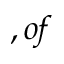<formula> <loc_0><loc_0><loc_500><loc_500>, o f</formula> 